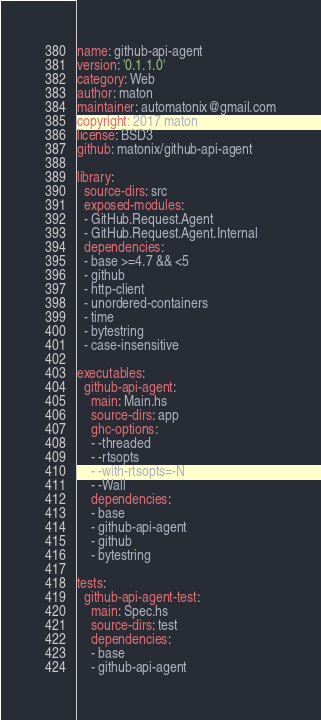Convert code to text. <code><loc_0><loc_0><loc_500><loc_500><_YAML_>name: github-api-agent
version: '0.1.1.0'
category: Web
author: maton
maintainer: automatonix@gmail.com
copyright: 2017 maton
license: BSD3
github: matonix/github-api-agent

library:
  source-dirs: src
  exposed-modules:
  - GitHub.Request.Agent
  - GitHub.Request.Agent.Internal
  dependencies:
  - base >=4.7 && <5
  - github
  - http-client
  - unordered-containers
  - time
  - bytestring
  - case-insensitive

executables:
  github-api-agent:
    main: Main.hs
    source-dirs: app
    ghc-options:
    - -threaded
    - -rtsopts
    - -with-rtsopts=-N
    - -Wall
    dependencies:
    - base
    - github-api-agent
    - github
    - bytestring

tests:
  github-api-agent-test:
    main: Spec.hs
    source-dirs: test
    dependencies:
    - base
    - github-api-agent
</code> 